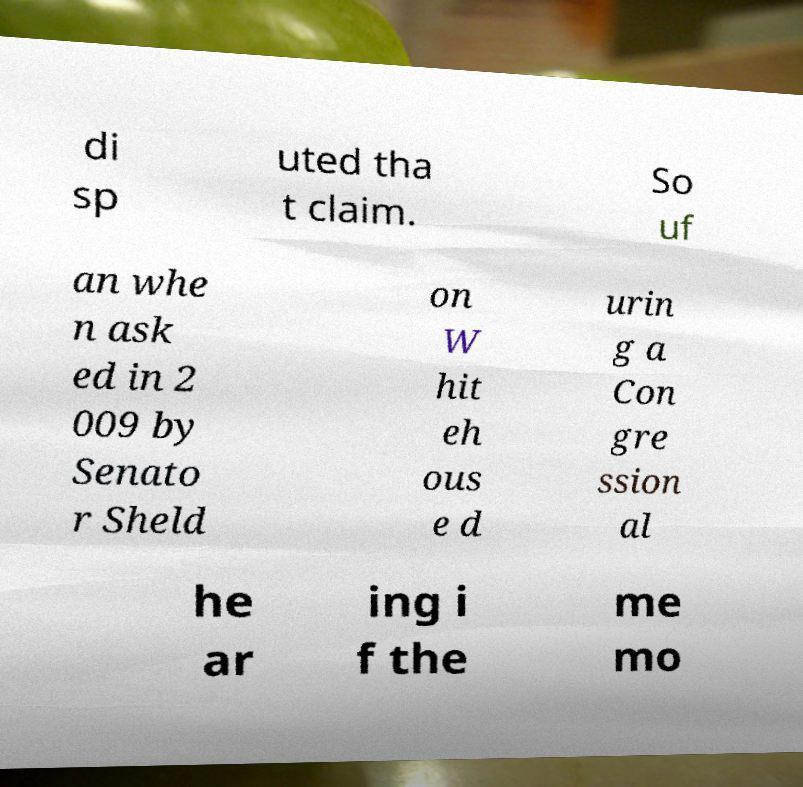For documentation purposes, I need the text within this image transcribed. Could you provide that? di sp uted tha t claim. So uf an whe n ask ed in 2 009 by Senato r Sheld on W hit eh ous e d urin g a Con gre ssion al he ar ing i f the me mo 